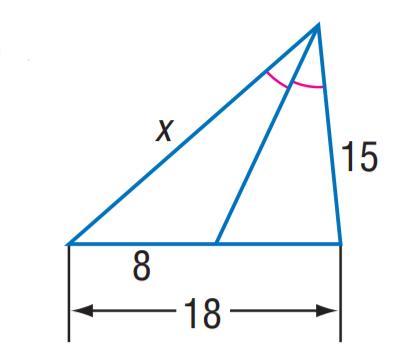Answer the mathemtical geometry problem and directly provide the correct option letter.
Question: Find x.
Choices: A: 8 B: 9 C: 12 D: 15 C 